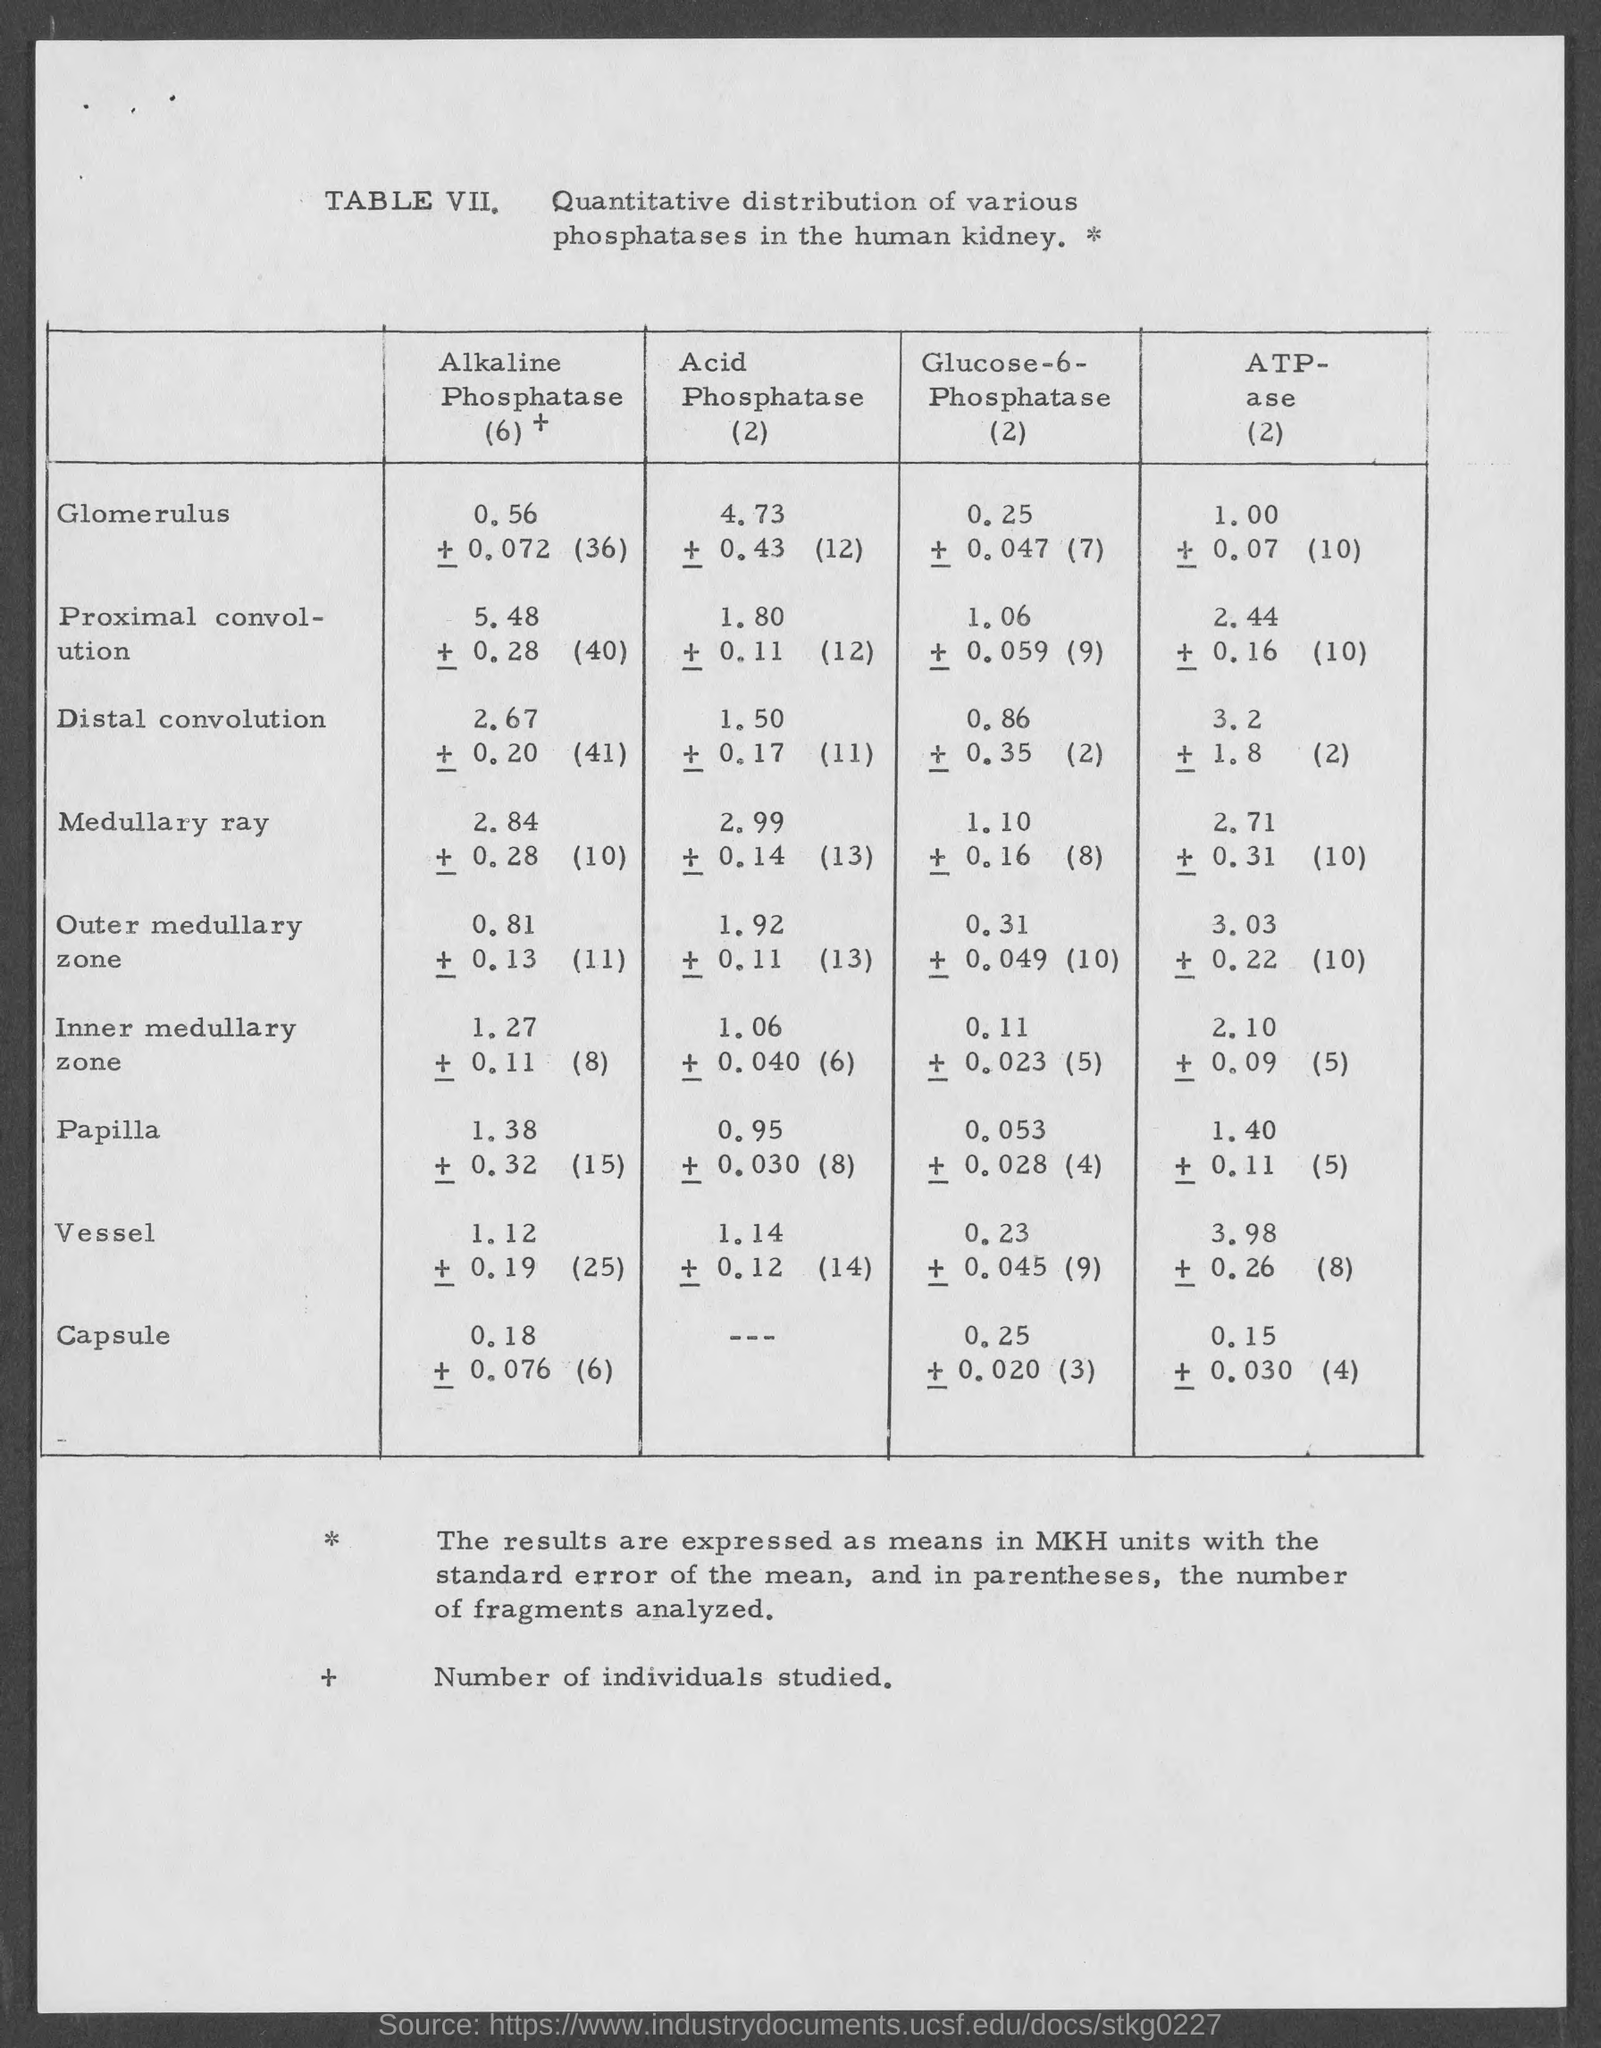Highlight a few significant elements in this photo. TABLE VIII provides a detailed description of the quantitative distribution of various phosphatases in the human kidney, highlighting their specific concentrations and functions within the organ. 